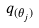Convert formula to latex. <formula><loc_0><loc_0><loc_500><loc_500>q _ { ( \theta _ { j } ) }</formula> 